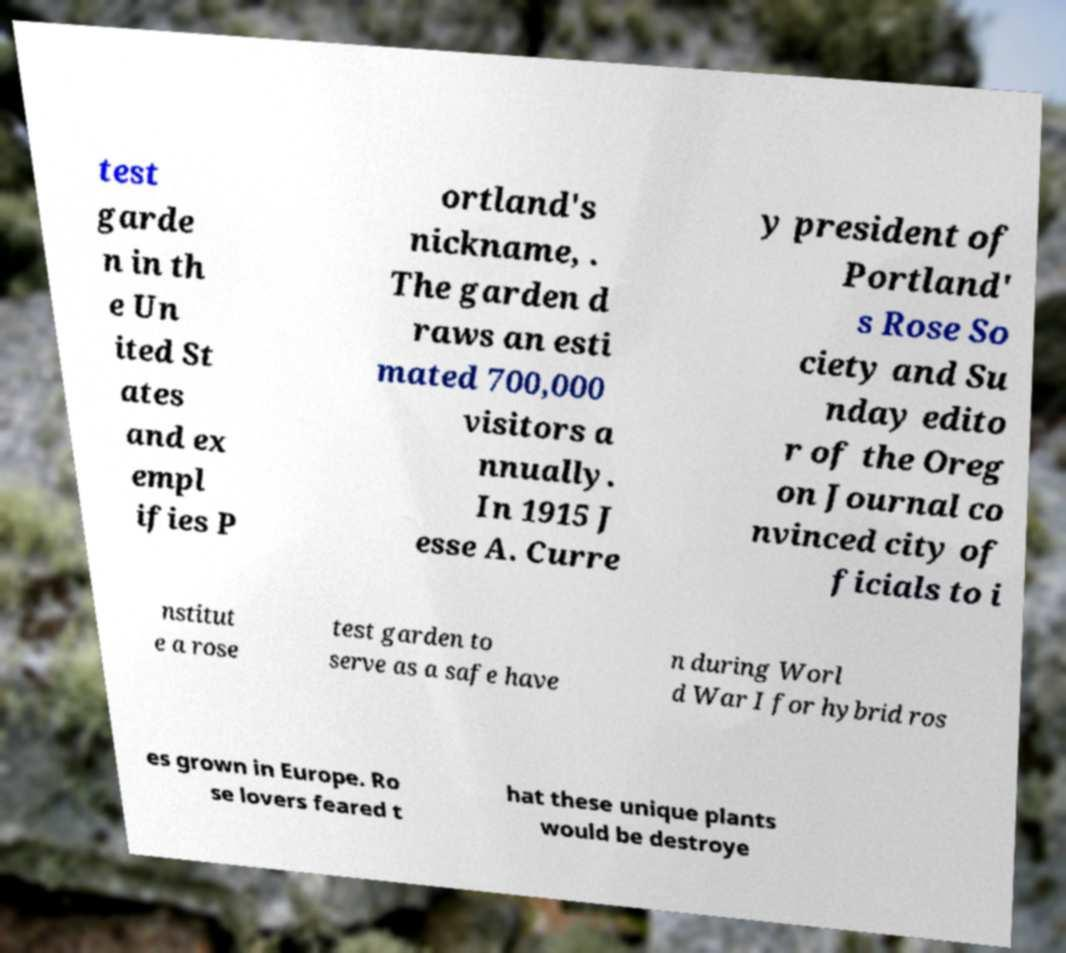Could you assist in decoding the text presented in this image and type it out clearly? test garde n in th e Un ited St ates and ex empl ifies P ortland's nickname, . The garden d raws an esti mated 700,000 visitors a nnually. In 1915 J esse A. Curre y president of Portland' s Rose So ciety and Su nday edito r of the Oreg on Journal co nvinced city of ficials to i nstitut e a rose test garden to serve as a safe have n during Worl d War I for hybrid ros es grown in Europe. Ro se lovers feared t hat these unique plants would be destroye 